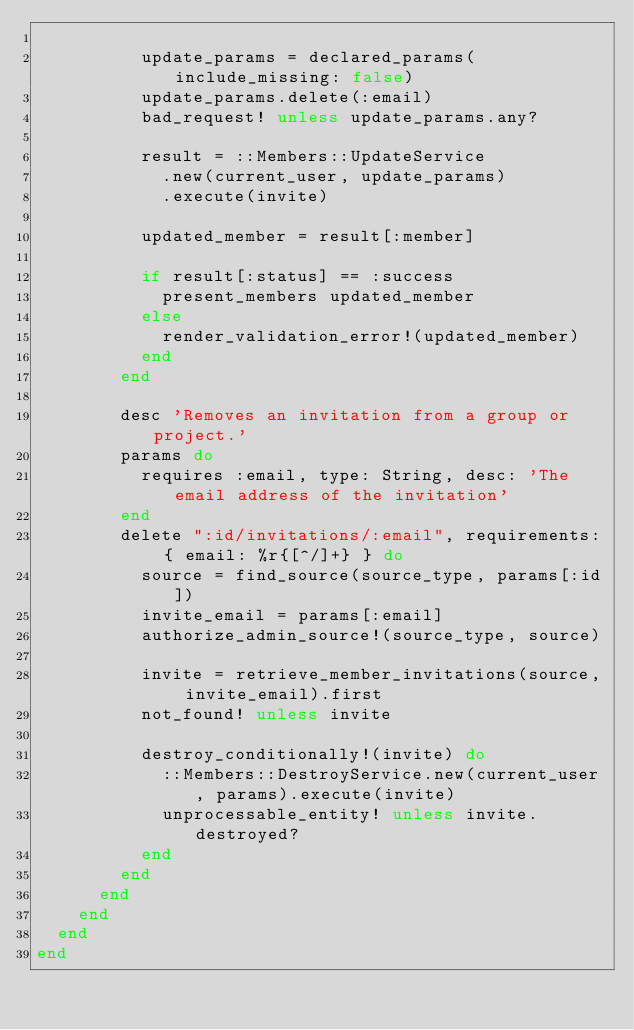Convert code to text. <code><loc_0><loc_0><loc_500><loc_500><_Ruby_>
          update_params = declared_params(include_missing: false)
          update_params.delete(:email)
          bad_request! unless update_params.any?

          result = ::Members::UpdateService
            .new(current_user, update_params)
            .execute(invite)

          updated_member = result[:member]

          if result[:status] == :success
            present_members updated_member
          else
            render_validation_error!(updated_member)
          end
        end

        desc 'Removes an invitation from a group or project.'
        params do
          requires :email, type: String, desc: 'The email address of the invitation'
        end
        delete ":id/invitations/:email", requirements: { email: %r{[^/]+} } do
          source = find_source(source_type, params[:id])
          invite_email = params[:email]
          authorize_admin_source!(source_type, source)

          invite = retrieve_member_invitations(source, invite_email).first
          not_found! unless invite

          destroy_conditionally!(invite) do
            ::Members::DestroyService.new(current_user, params).execute(invite)
            unprocessable_entity! unless invite.destroyed?
          end
        end
      end
    end
  end
end
</code> 